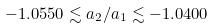<formula> <loc_0><loc_0><loc_500><loc_500>- 1 . 0 5 5 0 \lesssim a _ { 2 } / a _ { 1 } \lesssim - 1 . 0 4 0 0</formula> 